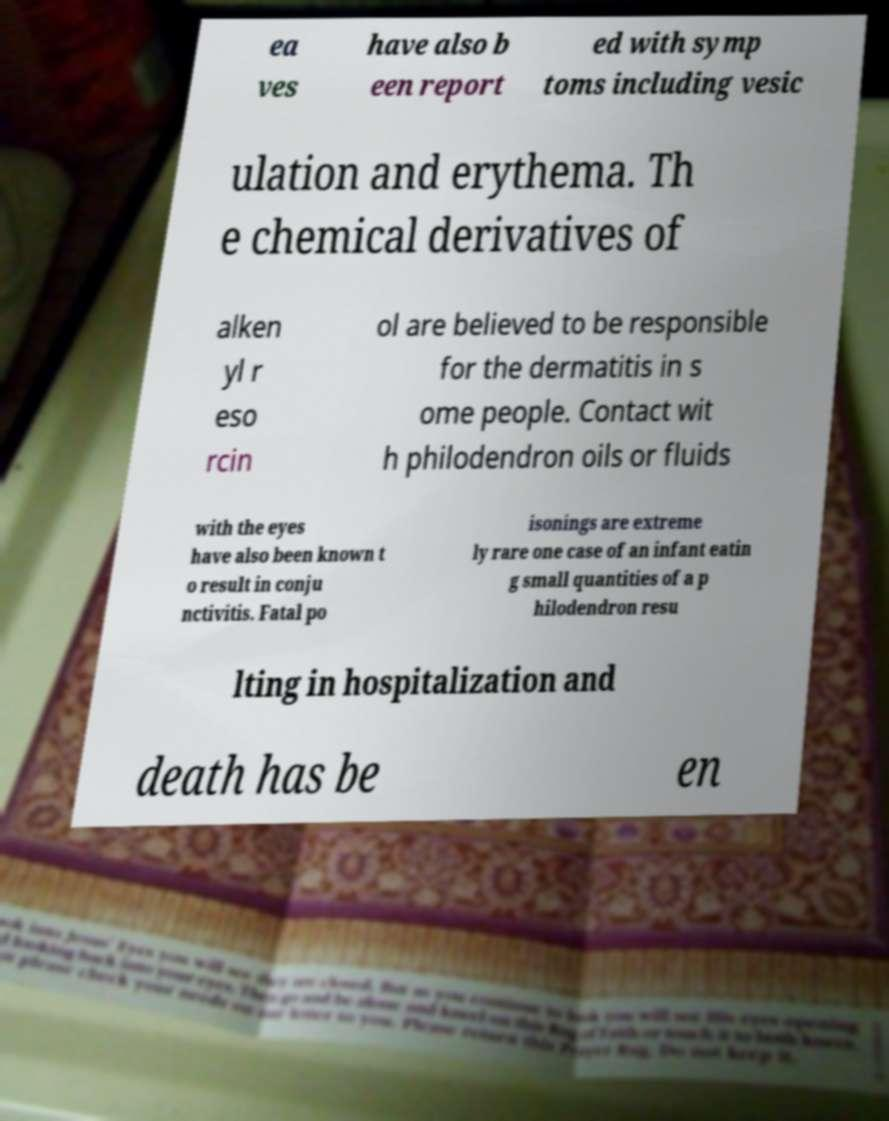What messages or text are displayed in this image? I need them in a readable, typed format. ea ves have also b een report ed with symp toms including vesic ulation and erythema. Th e chemical derivatives of alken yl r eso rcin ol are believed to be responsible for the dermatitis in s ome people. Contact wit h philodendron oils or fluids with the eyes have also been known t o result in conju nctivitis. Fatal po isonings are extreme ly rare one case of an infant eatin g small quantities of a p hilodendron resu lting in hospitalization and death has be en 